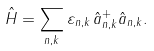<formula> <loc_0><loc_0><loc_500><loc_500>\hat { H } = \sum _ { n , { k } } \varepsilon _ { n , { k } } \, \hat { a } ^ { + } _ { n , { k } } \hat { a } _ { n , { k } } .</formula> 